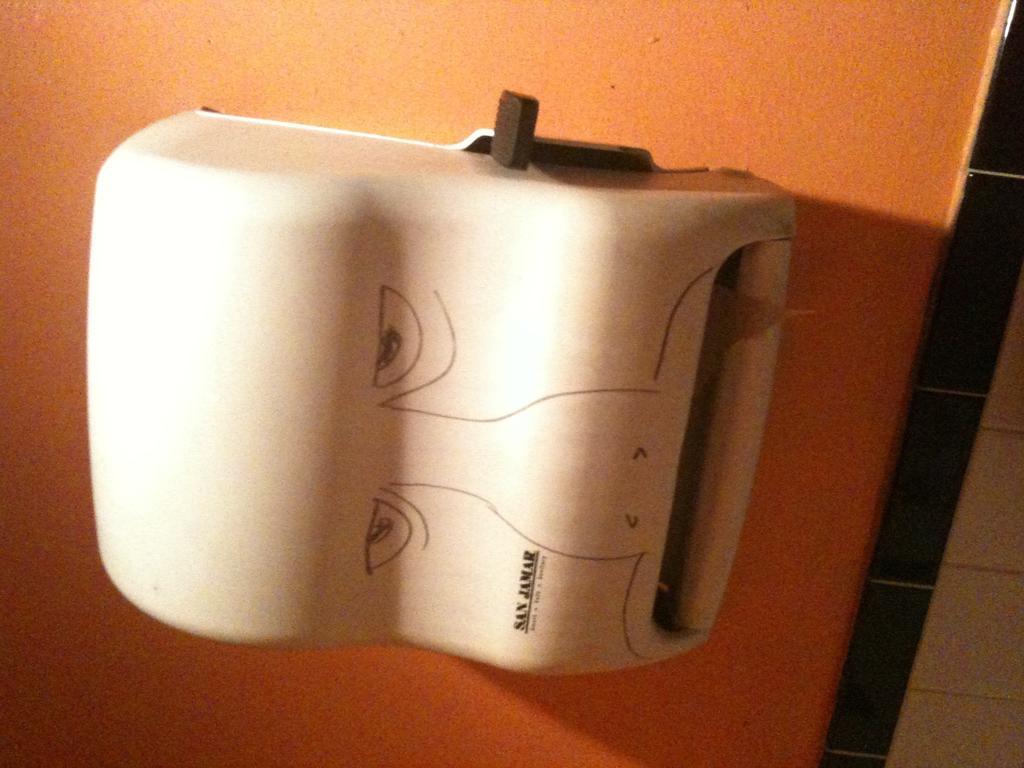Could you give a brief overview of what you see in this image? In this image I can see a white color box attached to the wall and the wall is in orange color. 